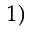Convert formula to latex. <formula><loc_0><loc_0><loc_500><loc_500>^ { 1 ) }</formula> 